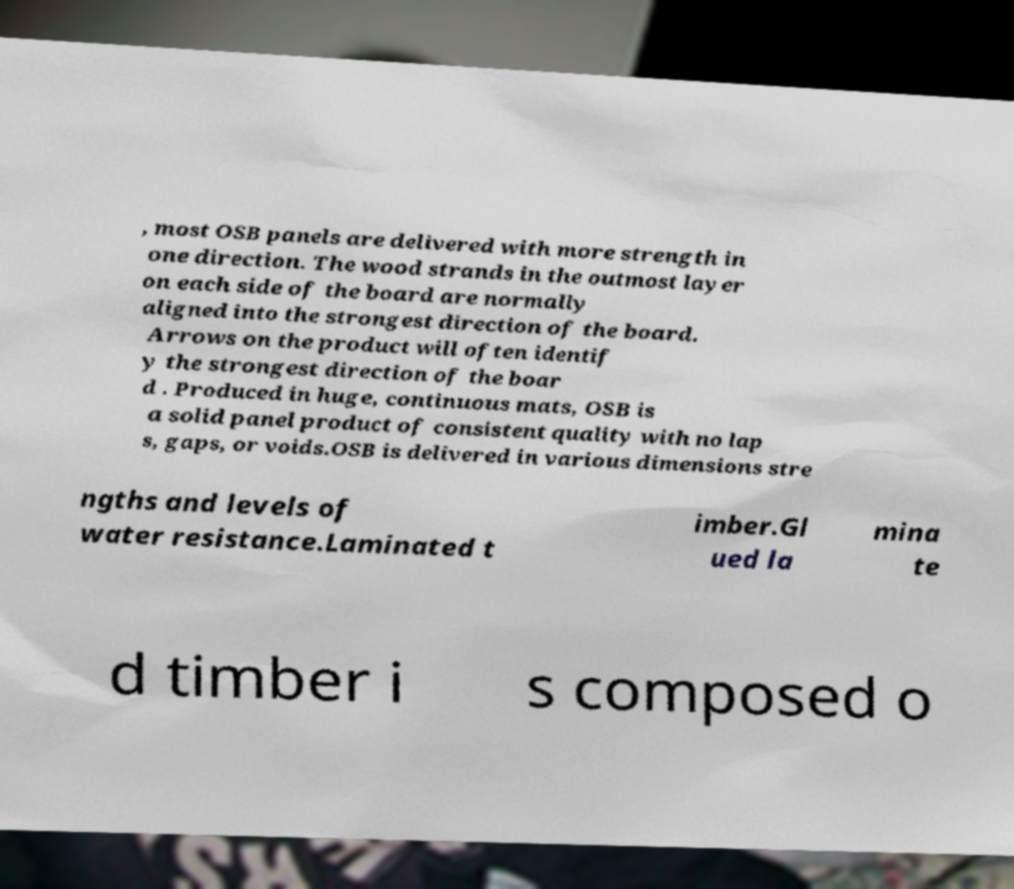Can you read and provide the text displayed in the image?This photo seems to have some interesting text. Can you extract and type it out for me? , most OSB panels are delivered with more strength in one direction. The wood strands in the outmost layer on each side of the board are normally aligned into the strongest direction of the board. Arrows on the product will often identif y the strongest direction of the boar d . Produced in huge, continuous mats, OSB is a solid panel product of consistent quality with no lap s, gaps, or voids.OSB is delivered in various dimensions stre ngths and levels of water resistance.Laminated t imber.Gl ued la mina te d timber i s composed o 